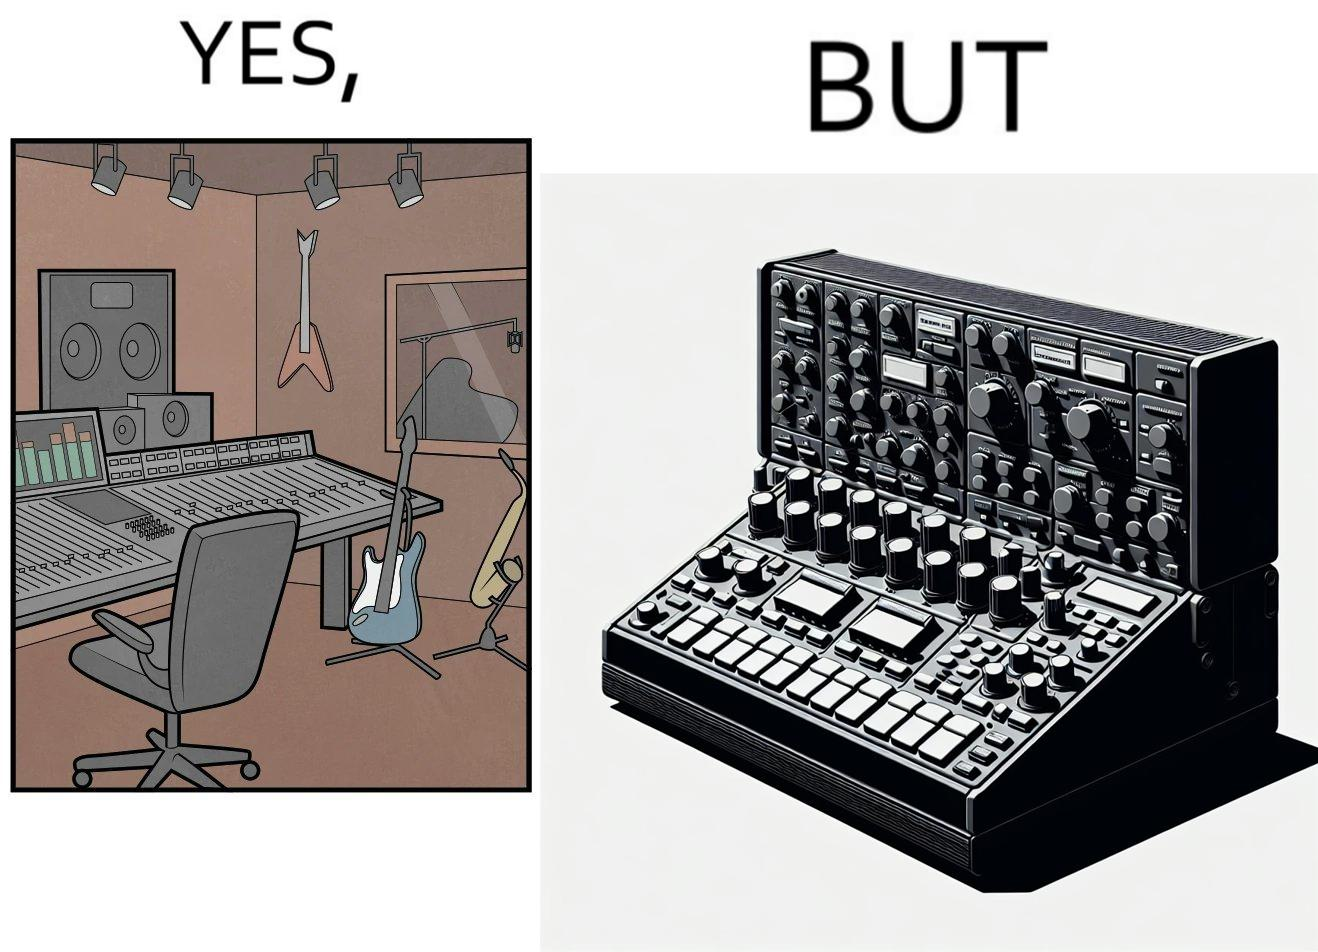Is this image satirical or non-satirical? Yes, this image is satirical. 